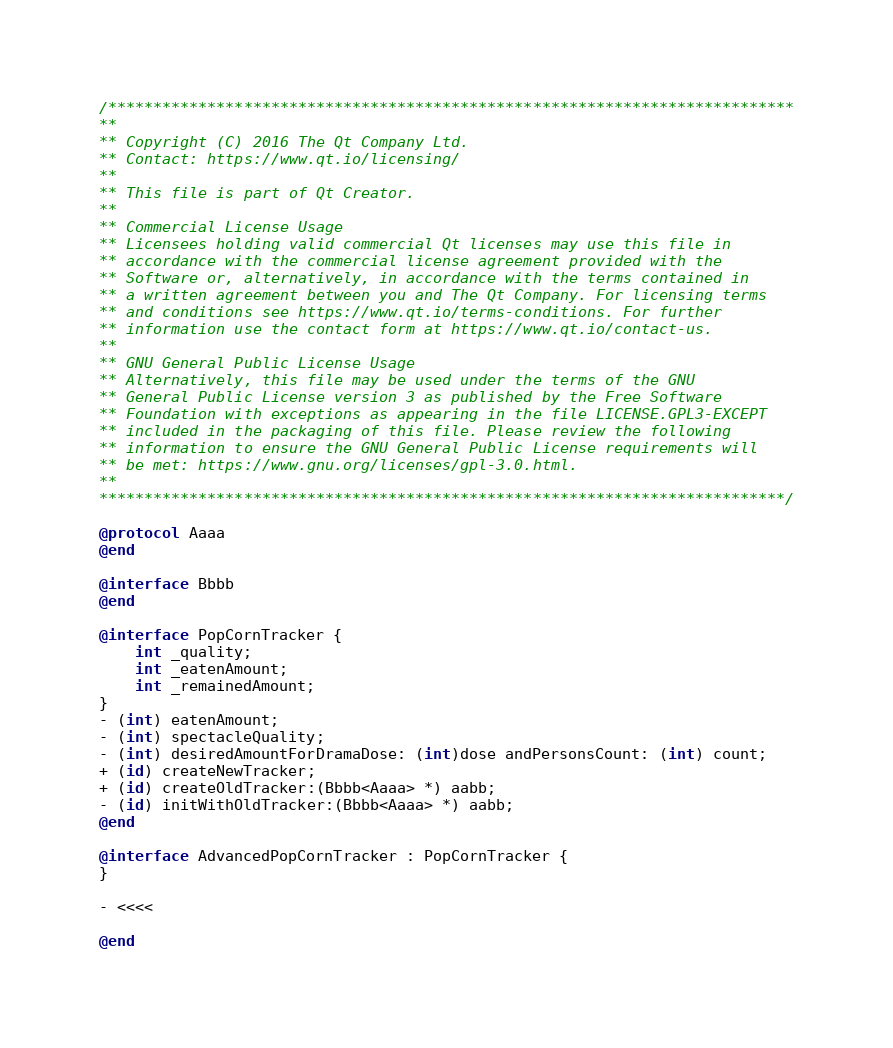<code> <loc_0><loc_0><loc_500><loc_500><_ObjectiveC_>/****************************************************************************
**
** Copyright (C) 2016 The Qt Company Ltd.
** Contact: https://www.qt.io/licensing/
**
** This file is part of Qt Creator.
**
** Commercial License Usage
** Licensees holding valid commercial Qt licenses may use this file in
** accordance with the commercial license agreement provided with the
** Software or, alternatively, in accordance with the terms contained in
** a written agreement between you and The Qt Company. For licensing terms
** and conditions see https://www.qt.io/terms-conditions. For further
** information use the contact form at https://www.qt.io/contact-us.
**
** GNU General Public License Usage
** Alternatively, this file may be used under the terms of the GNU
** General Public License version 3 as published by the Free Software
** Foundation with exceptions as appearing in the file LICENSE.GPL3-EXCEPT
** included in the packaging of this file. Please review the following
** information to ensure the GNU General Public License requirements will
** be met: https://www.gnu.org/licenses/gpl-3.0.html.
**
****************************************************************************/

@protocol Aaaa
@end

@interface Bbbb
@end

@interface PopCornTracker {
    int _quality;
    int _eatenAmount;
    int _remainedAmount;
}
- (int) eatenAmount;
- (int) spectacleQuality;
- (int) desiredAmountForDramaDose: (int)dose andPersonsCount: (int) count;
+ (id) createNewTracker;
+ (id) createOldTracker:(Bbbb<Aaaa> *) aabb;
- (id) initWithOldTracker:(Bbbb<Aaaa> *) aabb;
@end

@interface AdvancedPopCornTracker : PopCornTracker {
}

- <<<<

@end
</code> 